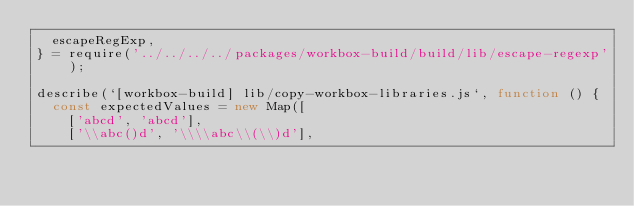Convert code to text. <code><loc_0><loc_0><loc_500><loc_500><_JavaScript_>  escapeRegExp,
} = require('../../../../packages/workbox-build/build/lib/escape-regexp');

describe(`[workbox-build] lib/copy-workbox-libraries.js`, function () {
  const expectedValues = new Map([
    ['abcd', 'abcd'],
    ['\\abc()d', '\\\\abc\\(\\)d'],</code> 